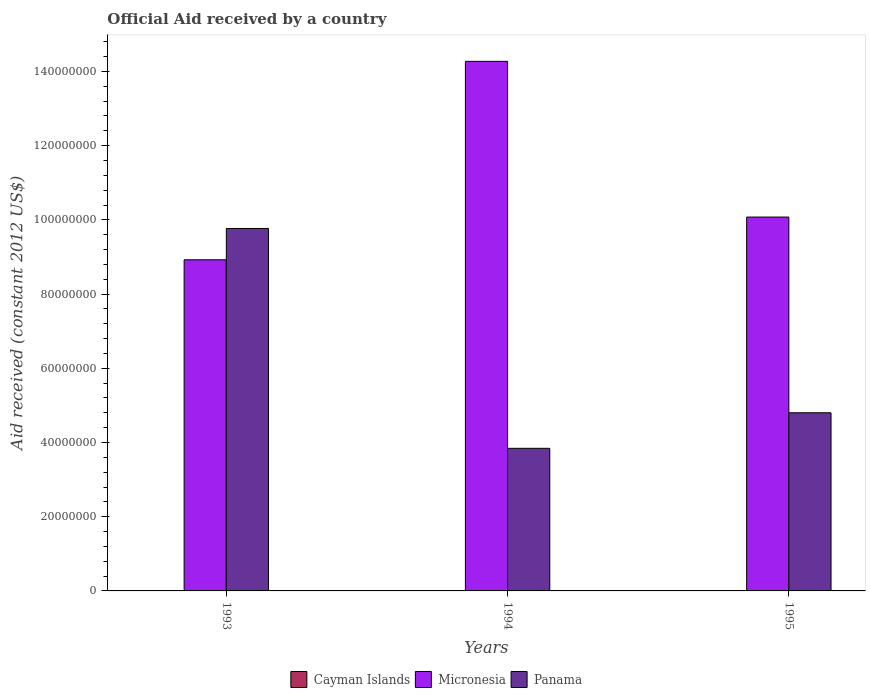Are the number of bars on each tick of the X-axis equal?
Your answer should be compact. Yes. How many bars are there on the 1st tick from the left?
Give a very brief answer. 2. How many bars are there on the 2nd tick from the right?
Offer a terse response. 2. Across all years, what is the maximum net official aid received in Micronesia?
Offer a terse response. 1.43e+08. Across all years, what is the minimum net official aid received in Micronesia?
Provide a short and direct response. 8.92e+07. What is the total net official aid received in Panama in the graph?
Your answer should be very brief. 1.84e+08. What is the difference between the net official aid received in Micronesia in 1993 and that in 1994?
Keep it short and to the point. -5.35e+07. What is the difference between the net official aid received in Panama in 1994 and the net official aid received in Micronesia in 1995?
Your answer should be compact. -6.23e+07. What is the average net official aid received in Micronesia per year?
Ensure brevity in your answer.  1.11e+08. In the year 1993, what is the difference between the net official aid received in Micronesia and net official aid received in Panama?
Offer a very short reply. -8.44e+06. In how many years, is the net official aid received in Micronesia greater than 36000000 US$?
Provide a short and direct response. 3. What is the ratio of the net official aid received in Micronesia in 1994 to that in 1995?
Ensure brevity in your answer.  1.42. Is the net official aid received in Micronesia in 1993 less than that in 1995?
Provide a short and direct response. Yes. Is the difference between the net official aid received in Micronesia in 1994 and 1995 greater than the difference between the net official aid received in Panama in 1994 and 1995?
Offer a terse response. Yes. What is the difference between the highest and the second highest net official aid received in Panama?
Your response must be concise. 4.97e+07. What is the difference between the highest and the lowest net official aid received in Panama?
Your response must be concise. 5.92e+07. In how many years, is the net official aid received in Cayman Islands greater than the average net official aid received in Cayman Islands taken over all years?
Your answer should be very brief. 0. Is the sum of the net official aid received in Micronesia in 1993 and 1995 greater than the maximum net official aid received in Panama across all years?
Your answer should be very brief. Yes. Are all the bars in the graph horizontal?
Provide a short and direct response. No. Are the values on the major ticks of Y-axis written in scientific E-notation?
Your answer should be compact. No. Does the graph contain any zero values?
Your answer should be compact. Yes. Where does the legend appear in the graph?
Offer a terse response. Bottom center. How many legend labels are there?
Make the answer very short. 3. How are the legend labels stacked?
Your response must be concise. Horizontal. What is the title of the graph?
Offer a terse response. Official Aid received by a country. Does "Brunei Darussalam" appear as one of the legend labels in the graph?
Offer a very short reply. No. What is the label or title of the Y-axis?
Provide a short and direct response. Aid received (constant 2012 US$). What is the Aid received (constant 2012 US$) in Micronesia in 1993?
Provide a succinct answer. 8.92e+07. What is the Aid received (constant 2012 US$) of Panama in 1993?
Offer a terse response. 9.77e+07. What is the Aid received (constant 2012 US$) of Micronesia in 1994?
Your response must be concise. 1.43e+08. What is the Aid received (constant 2012 US$) of Panama in 1994?
Make the answer very short. 3.84e+07. What is the Aid received (constant 2012 US$) in Cayman Islands in 1995?
Ensure brevity in your answer.  0. What is the Aid received (constant 2012 US$) in Micronesia in 1995?
Your answer should be very brief. 1.01e+08. What is the Aid received (constant 2012 US$) in Panama in 1995?
Keep it short and to the point. 4.80e+07. Across all years, what is the maximum Aid received (constant 2012 US$) in Micronesia?
Offer a very short reply. 1.43e+08. Across all years, what is the maximum Aid received (constant 2012 US$) in Panama?
Offer a terse response. 9.77e+07. Across all years, what is the minimum Aid received (constant 2012 US$) of Micronesia?
Ensure brevity in your answer.  8.92e+07. Across all years, what is the minimum Aid received (constant 2012 US$) in Panama?
Your answer should be very brief. 3.84e+07. What is the total Aid received (constant 2012 US$) in Cayman Islands in the graph?
Your answer should be compact. 0. What is the total Aid received (constant 2012 US$) of Micronesia in the graph?
Keep it short and to the point. 3.33e+08. What is the total Aid received (constant 2012 US$) in Panama in the graph?
Ensure brevity in your answer.  1.84e+08. What is the difference between the Aid received (constant 2012 US$) of Micronesia in 1993 and that in 1994?
Keep it short and to the point. -5.35e+07. What is the difference between the Aid received (constant 2012 US$) in Panama in 1993 and that in 1994?
Your response must be concise. 5.92e+07. What is the difference between the Aid received (constant 2012 US$) in Micronesia in 1993 and that in 1995?
Keep it short and to the point. -1.15e+07. What is the difference between the Aid received (constant 2012 US$) in Panama in 1993 and that in 1995?
Ensure brevity in your answer.  4.97e+07. What is the difference between the Aid received (constant 2012 US$) in Micronesia in 1994 and that in 1995?
Give a very brief answer. 4.20e+07. What is the difference between the Aid received (constant 2012 US$) of Panama in 1994 and that in 1995?
Your answer should be compact. -9.58e+06. What is the difference between the Aid received (constant 2012 US$) of Micronesia in 1993 and the Aid received (constant 2012 US$) of Panama in 1994?
Make the answer very short. 5.08e+07. What is the difference between the Aid received (constant 2012 US$) in Micronesia in 1993 and the Aid received (constant 2012 US$) in Panama in 1995?
Offer a very short reply. 4.12e+07. What is the difference between the Aid received (constant 2012 US$) in Micronesia in 1994 and the Aid received (constant 2012 US$) in Panama in 1995?
Offer a terse response. 9.47e+07. What is the average Aid received (constant 2012 US$) in Micronesia per year?
Your answer should be very brief. 1.11e+08. What is the average Aid received (constant 2012 US$) of Panama per year?
Keep it short and to the point. 6.14e+07. In the year 1993, what is the difference between the Aid received (constant 2012 US$) in Micronesia and Aid received (constant 2012 US$) in Panama?
Provide a short and direct response. -8.44e+06. In the year 1994, what is the difference between the Aid received (constant 2012 US$) in Micronesia and Aid received (constant 2012 US$) in Panama?
Provide a short and direct response. 1.04e+08. In the year 1995, what is the difference between the Aid received (constant 2012 US$) in Micronesia and Aid received (constant 2012 US$) in Panama?
Your answer should be very brief. 5.28e+07. What is the ratio of the Aid received (constant 2012 US$) of Micronesia in 1993 to that in 1994?
Your answer should be compact. 0.63. What is the ratio of the Aid received (constant 2012 US$) in Panama in 1993 to that in 1994?
Offer a terse response. 2.54. What is the ratio of the Aid received (constant 2012 US$) in Micronesia in 1993 to that in 1995?
Your answer should be compact. 0.89. What is the ratio of the Aid received (constant 2012 US$) of Panama in 1993 to that in 1995?
Offer a terse response. 2.03. What is the ratio of the Aid received (constant 2012 US$) in Micronesia in 1994 to that in 1995?
Ensure brevity in your answer.  1.42. What is the ratio of the Aid received (constant 2012 US$) in Panama in 1994 to that in 1995?
Your answer should be very brief. 0.8. What is the difference between the highest and the second highest Aid received (constant 2012 US$) of Micronesia?
Ensure brevity in your answer.  4.20e+07. What is the difference between the highest and the second highest Aid received (constant 2012 US$) in Panama?
Provide a succinct answer. 4.97e+07. What is the difference between the highest and the lowest Aid received (constant 2012 US$) in Micronesia?
Make the answer very short. 5.35e+07. What is the difference between the highest and the lowest Aid received (constant 2012 US$) of Panama?
Offer a very short reply. 5.92e+07. 